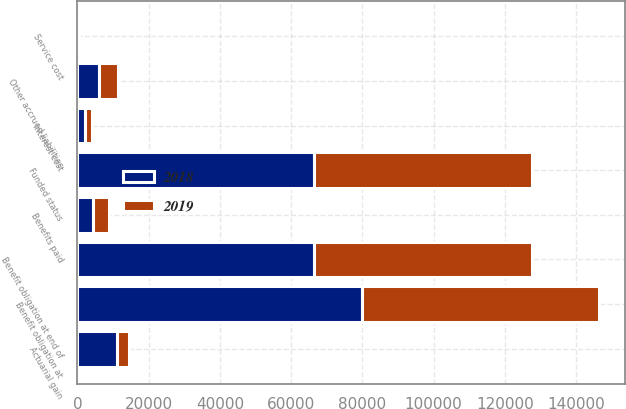Convert chart to OTSL. <chart><loc_0><loc_0><loc_500><loc_500><stacked_bar_chart><ecel><fcel>Benefit obligation at<fcel>Service cost<fcel>Interest cost<fcel>Actuarial gain<fcel>Benefits paid<fcel>Benefit obligation at end of<fcel>Funded status<fcel>Other accrued liabilities<nl><fcel>2019<fcel>66521<fcel>205<fcel>2043<fcel>3235<fcel>4536<fcel>60998<fcel>60998<fcel>5308<nl><fcel>2018<fcel>79933<fcel>320<fcel>2003<fcel>11259<fcel>4476<fcel>66521<fcel>66521<fcel>6180<nl></chart> 